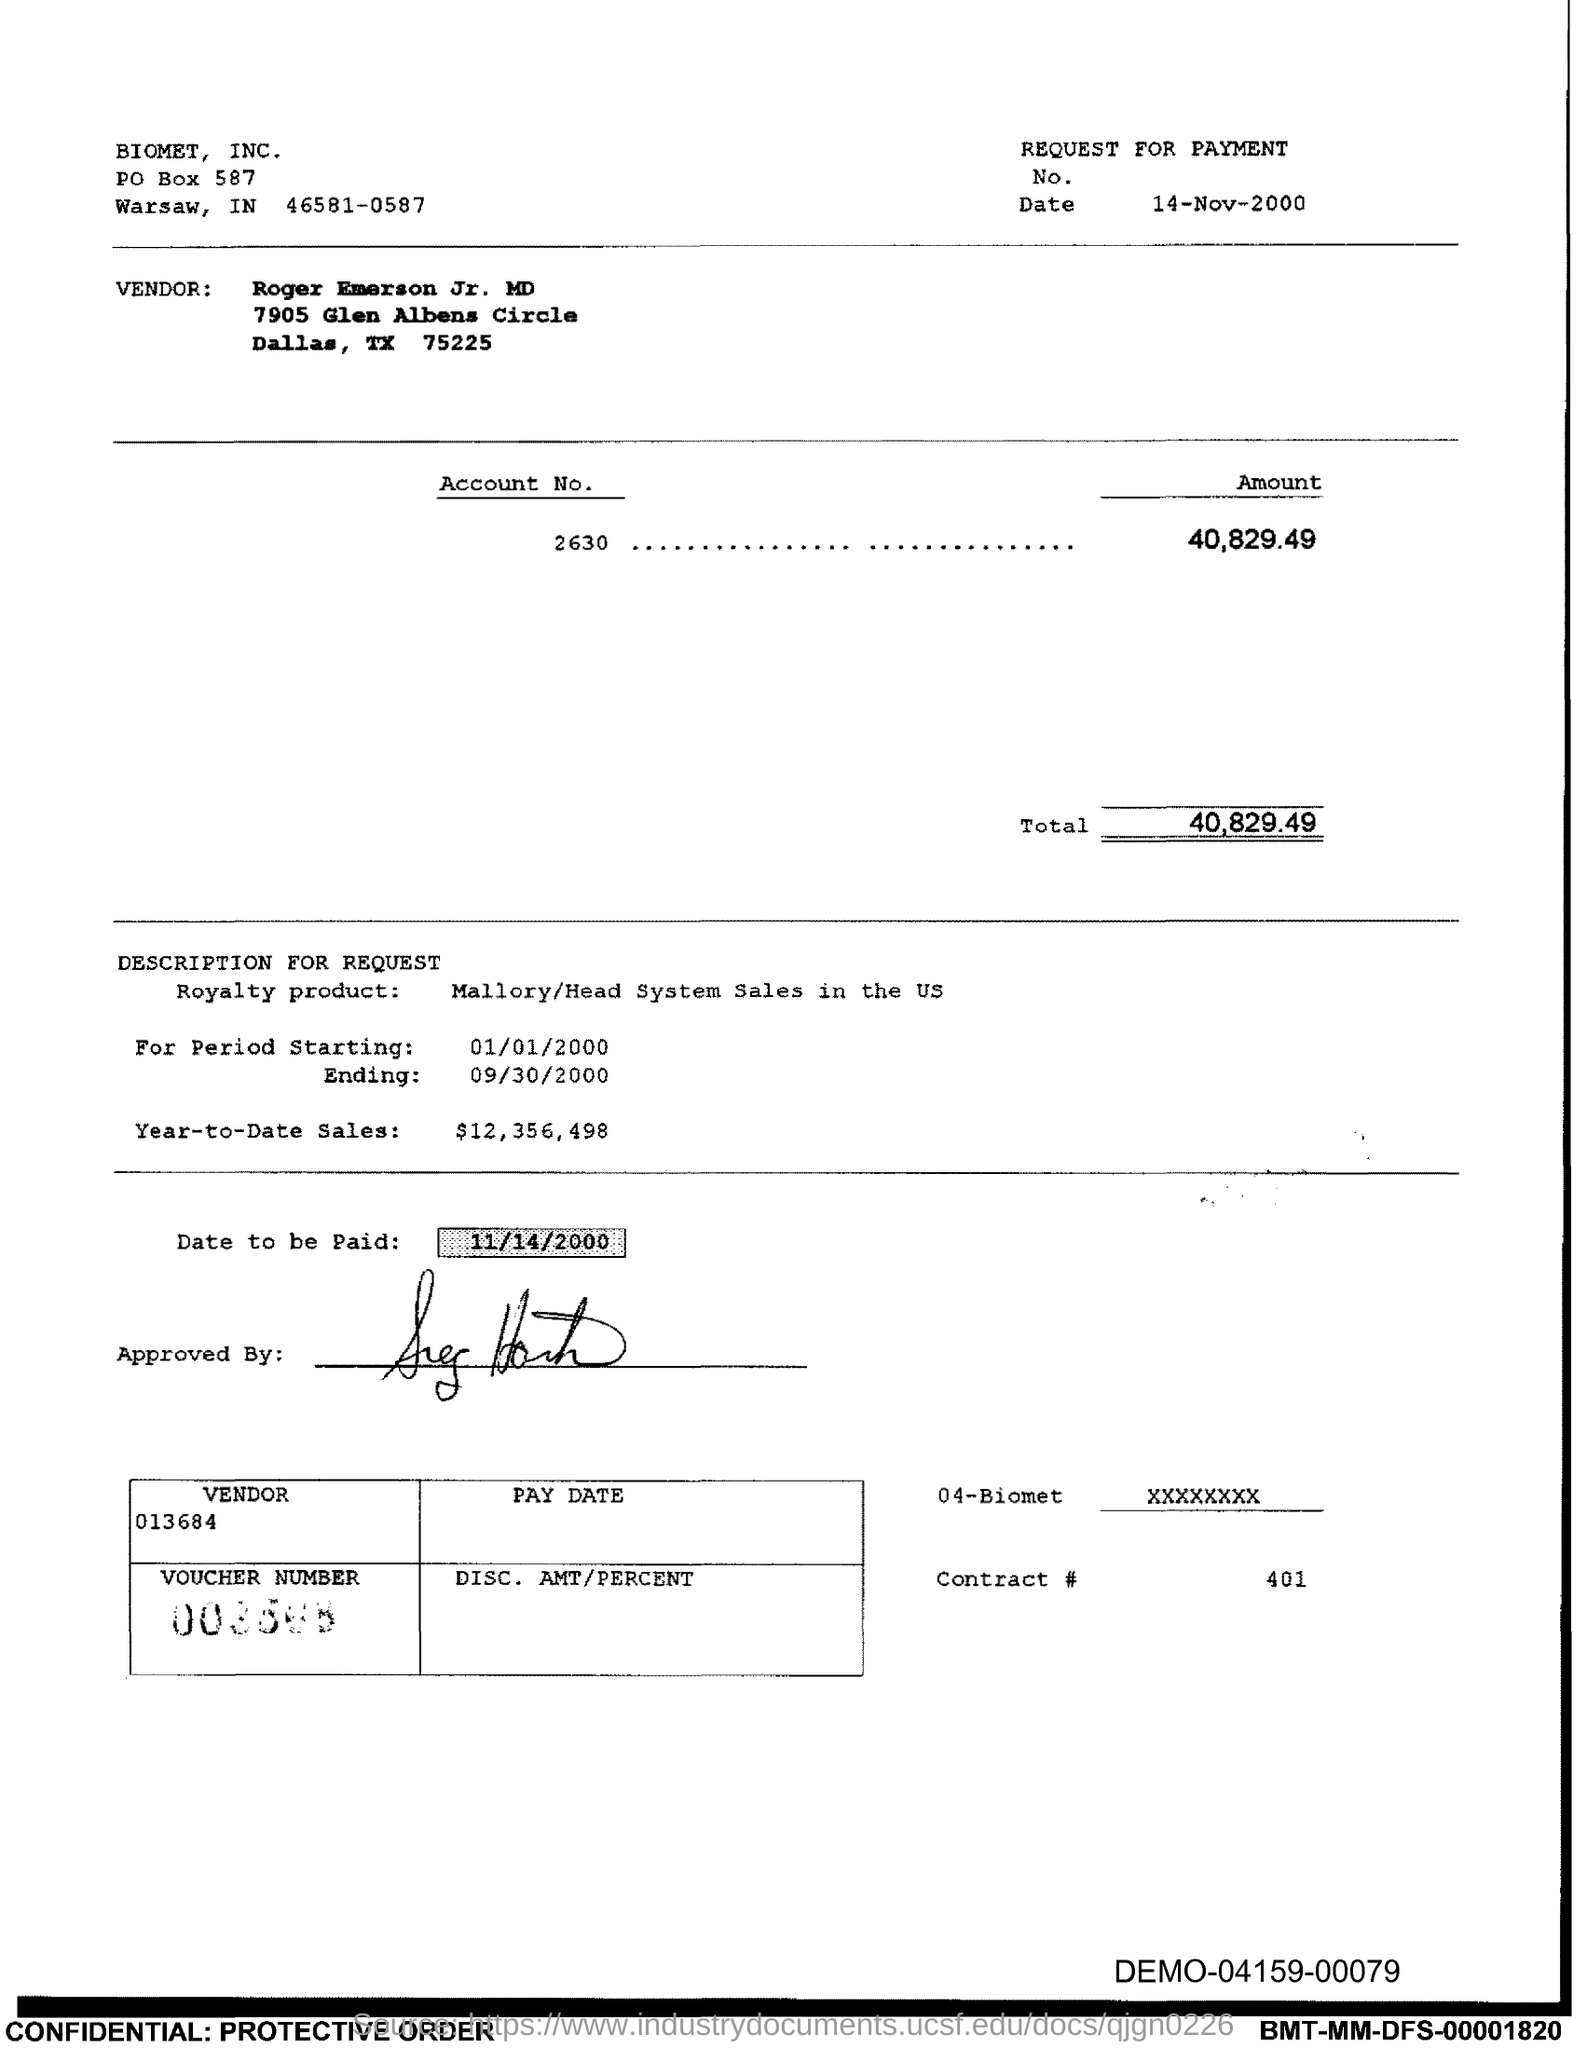What is the vendor name mentioned in the voucher?
Give a very brief answer. Roger Emerson Jr. MD. What is the Account No. given in the voucher?
Provide a short and direct response. 2630. What is the issued date of this voucher?
Offer a terse response. 14-Nov-2000. What is the total amount to be paid given in the voucher?
Offer a very short reply. 40,829.49. What is the royalty product given in the voucher?
Offer a very short reply. Mallory/Head System Sales in the US. What is the Year-to-Date Sales of the royalty product?
Give a very brief answer. $12,356,498. What is the start date of the royalty period?
Make the answer very short. 01/01/2000. What is the Contract # given in the voucher?
Provide a short and direct response. 401. What is the end date of the royalty period?
Give a very brief answer. 09/30/2000. Which company is mentioned in the header of the document?
Give a very brief answer. BIOMET, INC. 